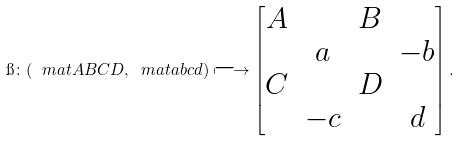Convert formula to latex. <formula><loc_0><loc_0><loc_500><loc_500>\i \colon ( \ m a t { A } { B } { C } { D } , \ m a t { a } { b } { c } { d } ) \longmapsto \begin{bmatrix} A & & B \\ & a & & - b \\ C & & D \\ & - c & & d \end{bmatrix} .</formula> 